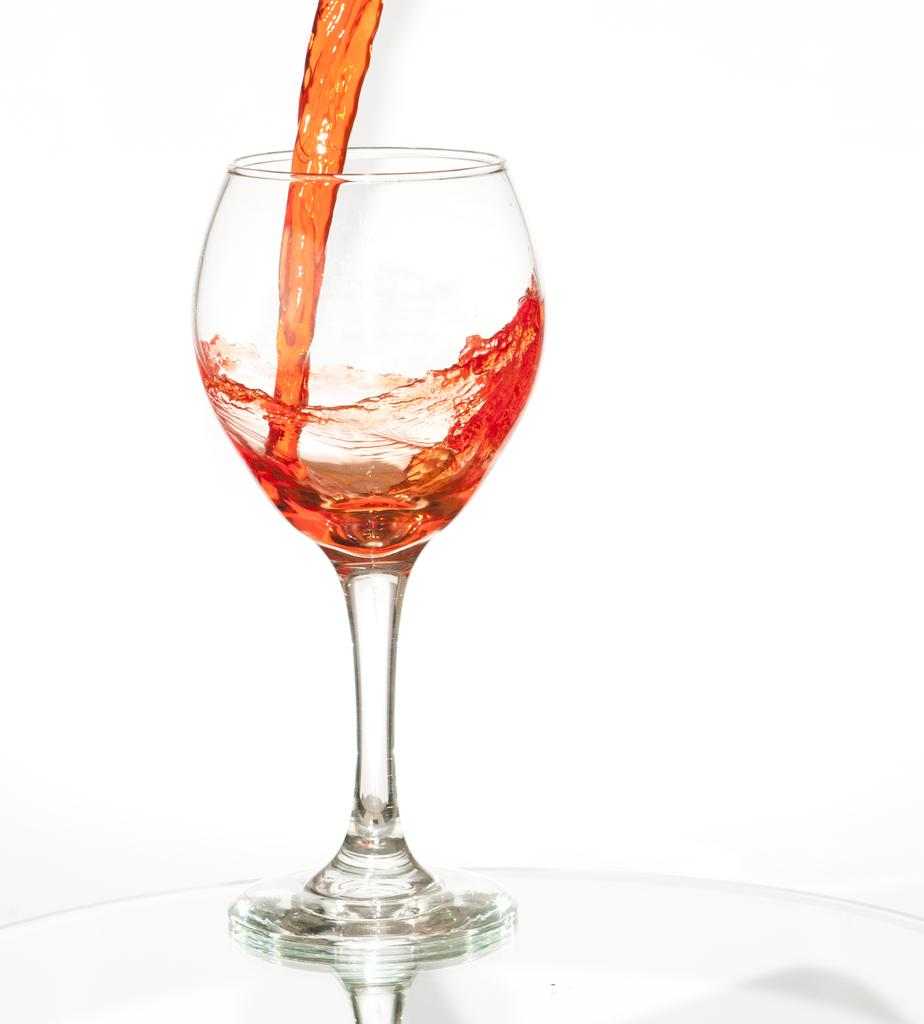What is in the image that is typically used for drinking? There is a wine glass in the image. What is being poured into the wine glass? A drink is being poured into the wine glass. What color is the background of the image? The background of the image is white. What type of calculator is being used to measure the liquid in the image? There is no calculator present in the image, and the liquid is being poured into a wine glass, not measured. 